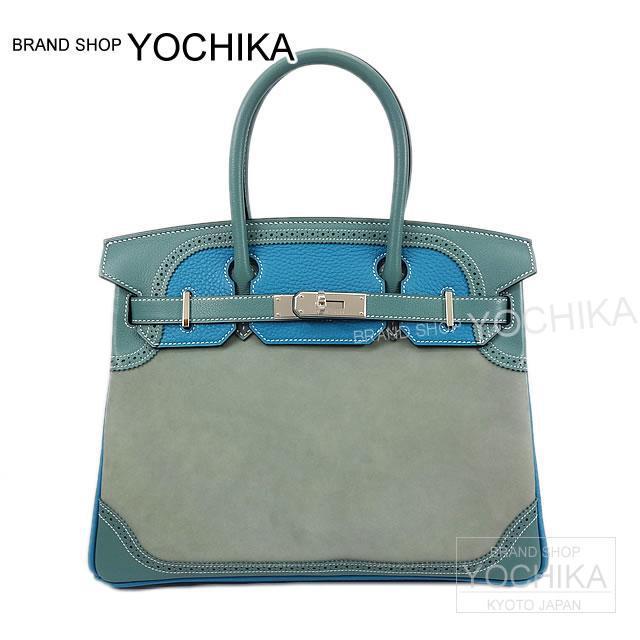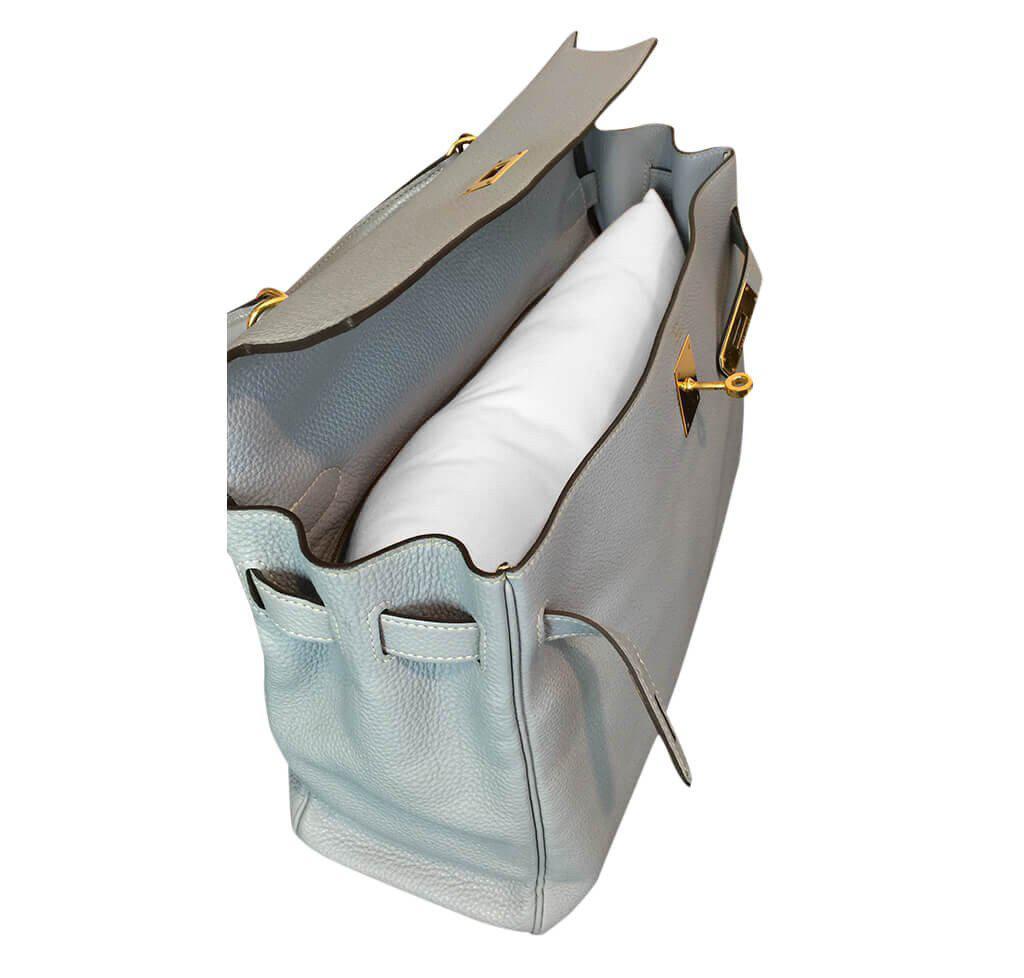The first image is the image on the left, the second image is the image on the right. Considering the images on both sides, is "The image on the right shows two purses and a purse pillow." valid? Answer yes or no. No. The first image is the image on the left, the second image is the image on the right. Assess this claim about the two images: "The right image shows an upright coral-colored handbag to the left of an upright tan handbag, and a white wedge pillow is in front of them.". Correct or not? Answer yes or no. No. 